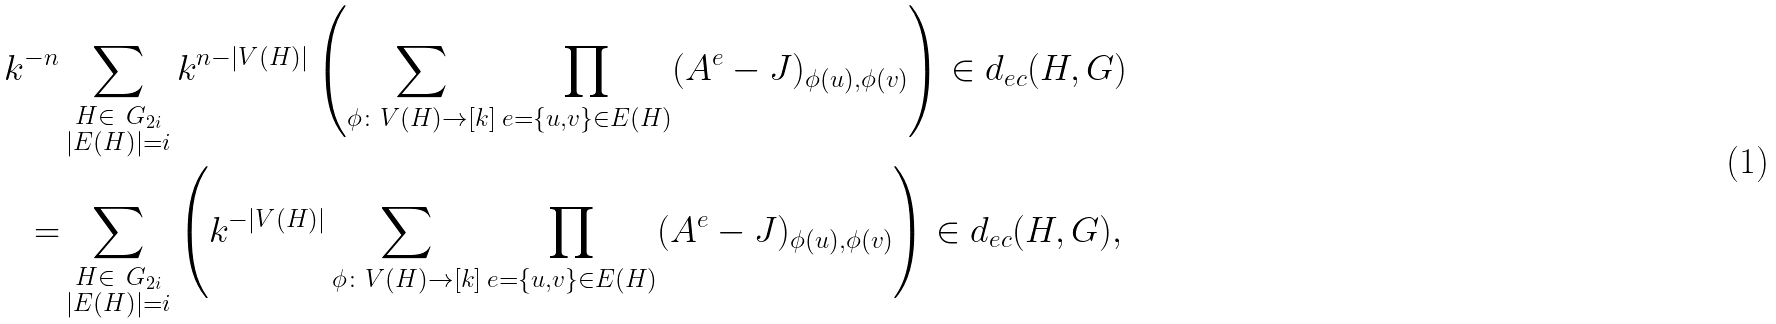Convert formula to latex. <formula><loc_0><loc_0><loc_500><loc_500>k ^ { - n } & \sum _ { \substack { H \in \ G _ { 2 i } \\ | E ( H ) | = i } } k ^ { n - | V ( H ) | } \left ( \sum _ { \phi \colon V ( H ) \to [ k ] } \prod _ { e = \{ u , v \} \in E ( H ) } ( A ^ { e } - J ) _ { \phi ( u ) , \phi ( v ) } \right ) \in d _ { e c } ( H , G ) \\ = & \sum _ { \substack { H \in \ G _ { 2 i } \\ | E ( H ) | = i } } \left ( k ^ { - | V ( H ) | } \sum _ { \phi \colon V ( H ) \to [ k ] } \prod _ { e = \{ u , v \} \in E ( H ) } ( A ^ { e } - J ) _ { \phi ( u ) , \phi ( v ) } \right ) \in d _ { e c } ( H , G ) ,</formula> 